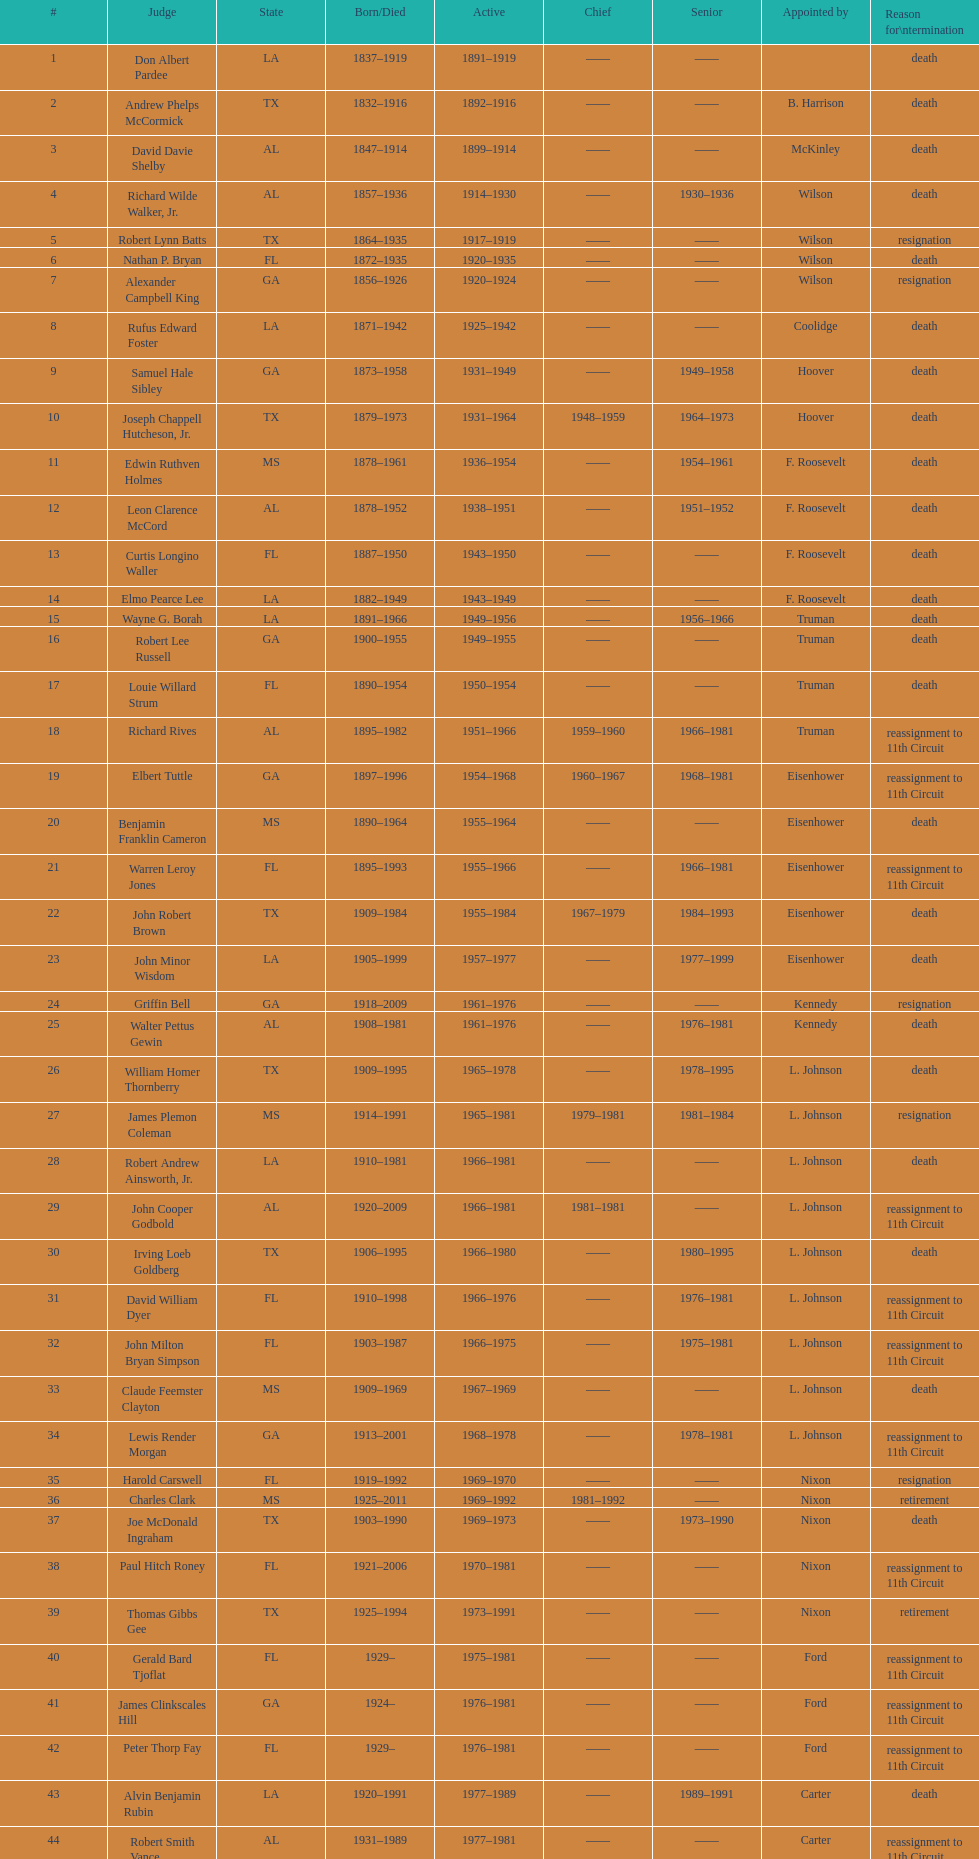Who was the inaugural judge from florida to hold the post? Nathan P. Bryan. 